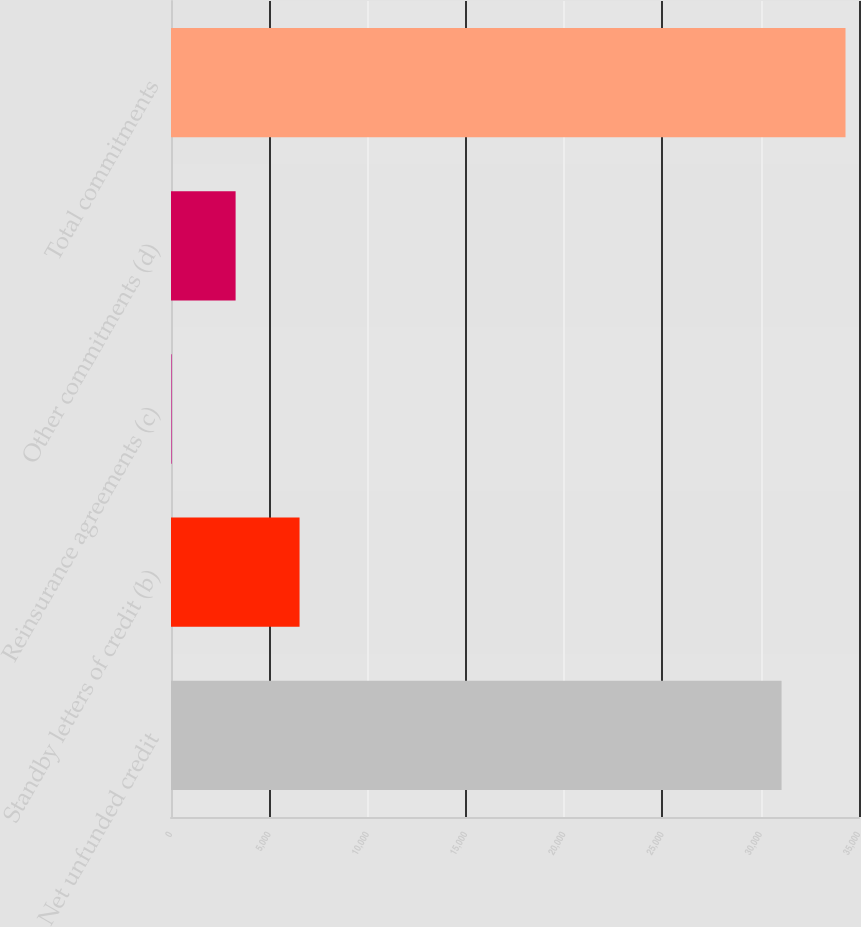Convert chart. <chart><loc_0><loc_0><loc_500><loc_500><bar_chart><fcel>Net unfunded credit<fcel>Standby letters of credit (b)<fcel>Reinsurance agreements (c)<fcel>Other commitments (d)<fcel>Total commitments<nl><fcel>31060<fcel>6540<fcel>33<fcel>3286.5<fcel>34313.5<nl></chart> 